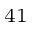<formula> <loc_0><loc_0><loc_500><loc_500>^ { 4 1 }</formula> 